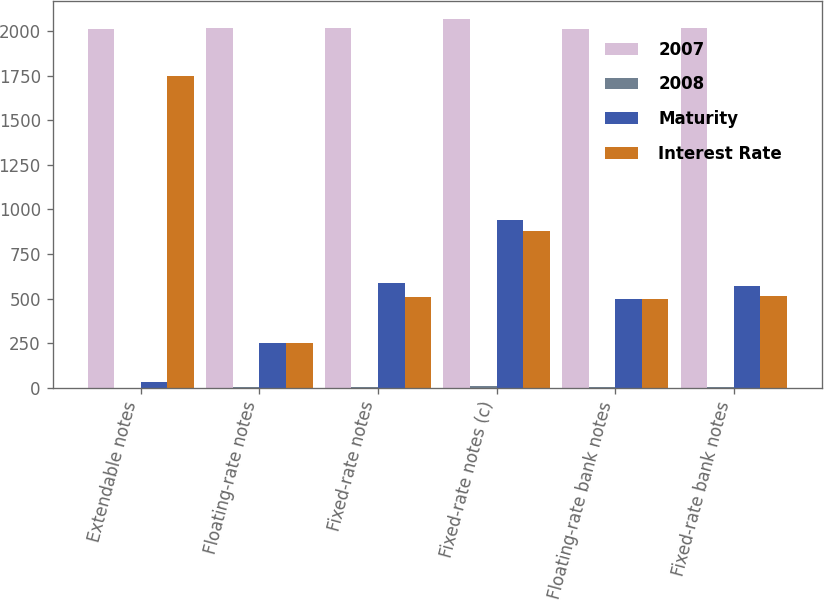Convert chart. <chart><loc_0><loc_0><loc_500><loc_500><stacked_bar_chart><ecel><fcel>Extendable notes<fcel>Floating-rate notes<fcel>Fixed-rate notes<fcel>Fixed-rate notes (c)<fcel>Floating-rate bank notes<fcel>Fixed-rate bank notes<nl><fcel>2007<fcel>2009<fcel>2016<fcel>2017<fcel>2067<fcel>2013<fcel>2015<nl><fcel>2008<fcel>0.49<fcel>1.95<fcel>5.45<fcel>7.25<fcel>2.26<fcel>4.75<nl><fcel>Maturity<fcel>31<fcel>250<fcel>588<fcel>942<fcel>500<fcel>573<nl><fcel>Interest Rate<fcel>1745<fcel>250<fcel>510<fcel>876<fcel>500<fcel>513<nl></chart> 